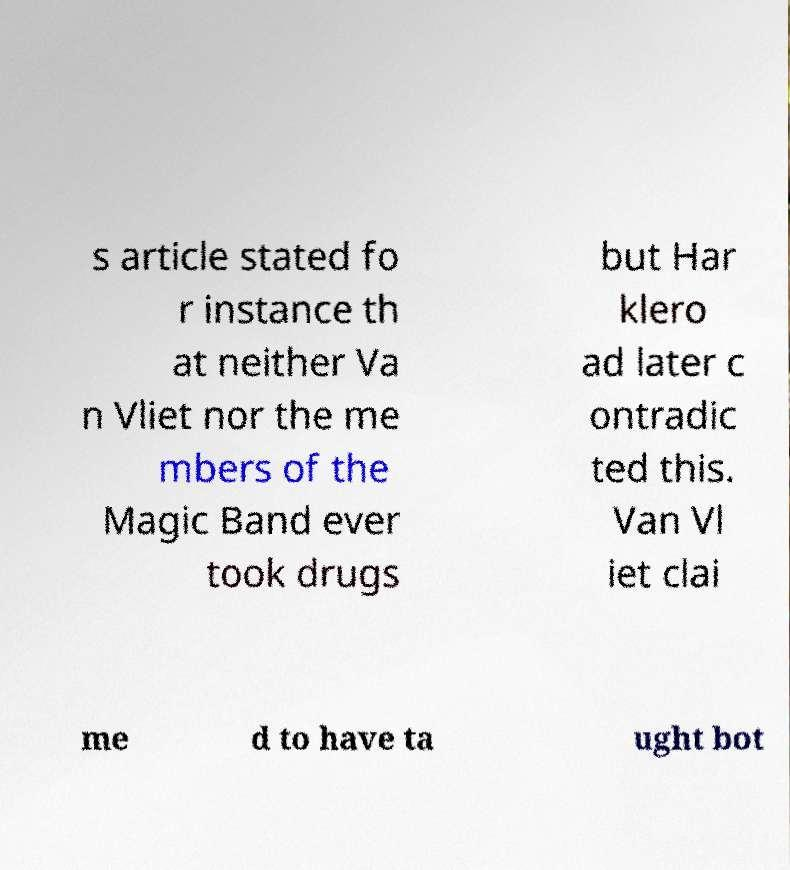Please read and relay the text visible in this image. What does it say? s article stated fo r instance th at neither Va n Vliet nor the me mbers of the Magic Band ever took drugs but Har klero ad later c ontradic ted this. Van Vl iet clai me d to have ta ught bot 